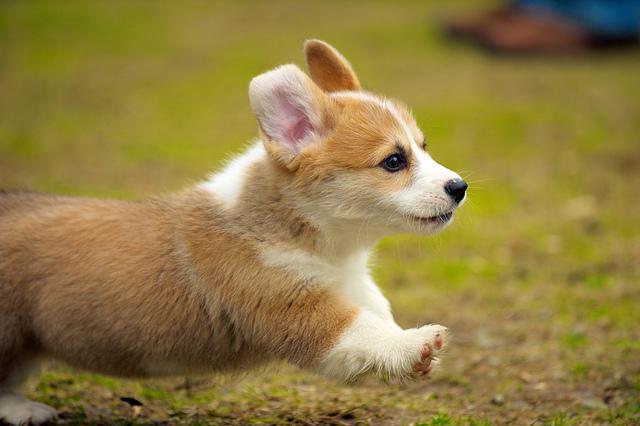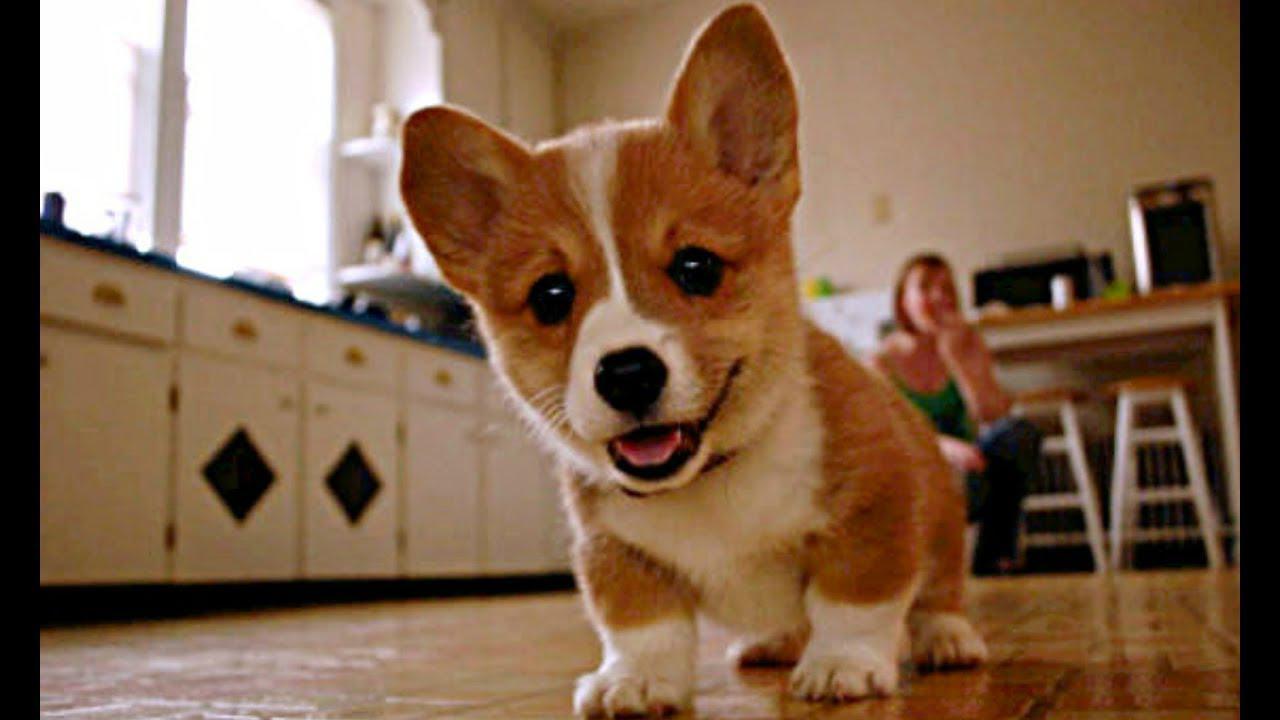The first image is the image on the left, the second image is the image on the right. Evaluate the accuracy of this statement regarding the images: "There are three dogs.". Is it true? Answer yes or no. No. The first image is the image on the left, the second image is the image on the right. Analyze the images presented: Is the assertion "One image contains twice as many dogs as the other image and includes a dog standing on all fours facing forward." valid? Answer yes or no. No. 